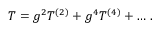<formula> <loc_0><loc_0><loc_500><loc_500>T = g ^ { 2 } T ^ { ( 2 ) } + g ^ { 4 } T ^ { ( 4 ) } + \dots \, .</formula> 